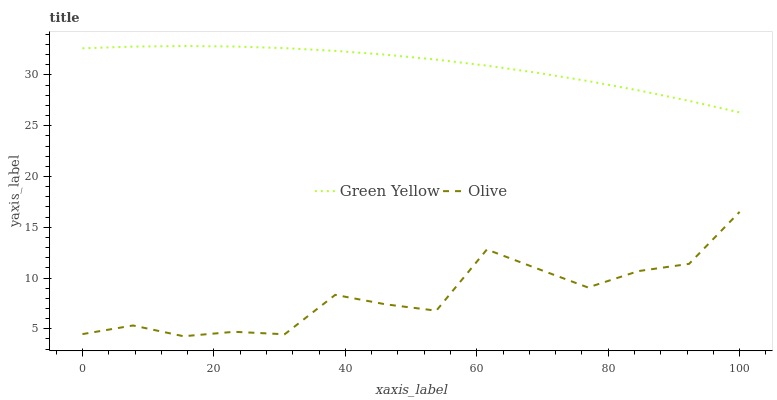Does Olive have the minimum area under the curve?
Answer yes or no. Yes. Does Green Yellow have the maximum area under the curve?
Answer yes or no. Yes. Does Green Yellow have the minimum area under the curve?
Answer yes or no. No. Is Green Yellow the smoothest?
Answer yes or no. Yes. Is Olive the roughest?
Answer yes or no. Yes. Is Green Yellow the roughest?
Answer yes or no. No. Does Olive have the lowest value?
Answer yes or no. Yes. Does Green Yellow have the lowest value?
Answer yes or no. No. Does Green Yellow have the highest value?
Answer yes or no. Yes. Is Olive less than Green Yellow?
Answer yes or no. Yes. Is Green Yellow greater than Olive?
Answer yes or no. Yes. Does Olive intersect Green Yellow?
Answer yes or no. No. 